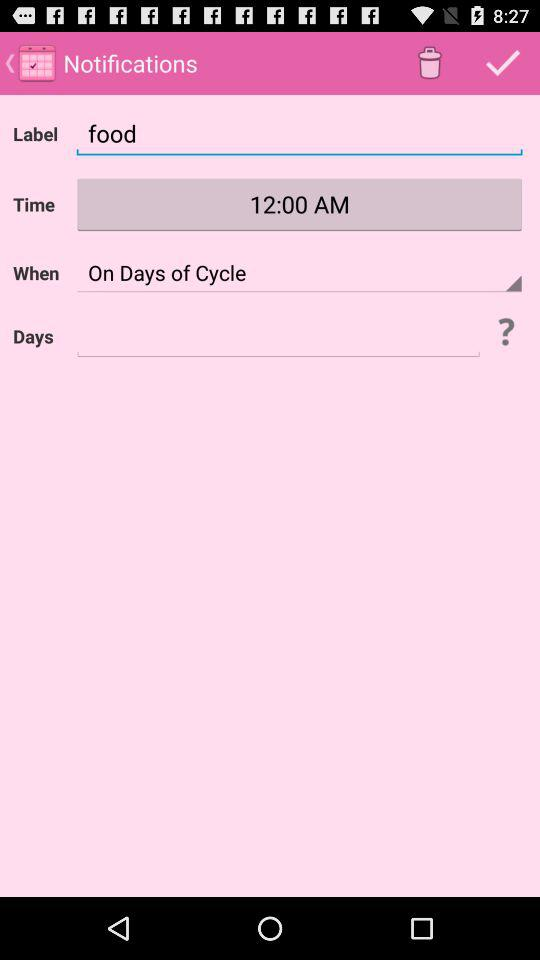What's the label? The label is food. 